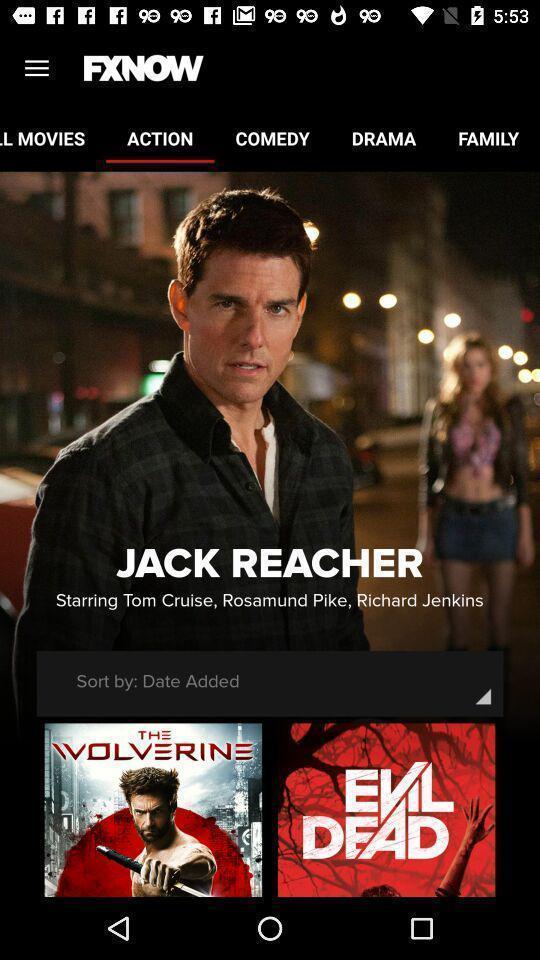Summarize the information in this screenshot. Screen shows about action movies. 